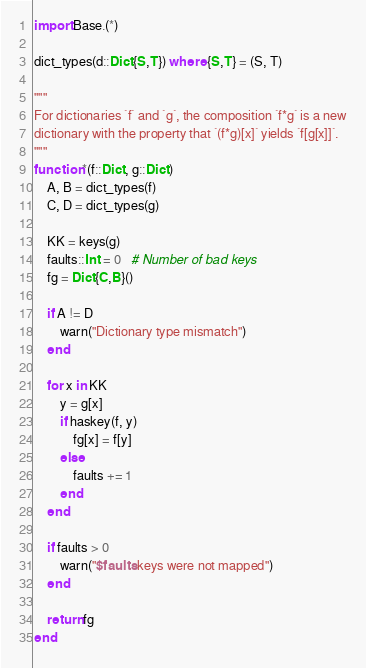<code> <loc_0><loc_0><loc_500><loc_500><_Julia_>import Base.(*)

dict_types(d::Dict{S,T}) where {S,T} = (S, T)

"""
For dictionaries `f` and `g`, the composition `f*g` is a new
dictionary with the property that `(f*g)[x]` yields `f[g[x]]`.
"""
function *(f::Dict, g::Dict)
    A, B = dict_types(f)
    C, D = dict_types(g)

    KK = keys(g)
    faults::Int = 0   # Number of bad keys
    fg = Dict{C,B}()

    if A != D
        warn("Dictionary type mismatch")
    end

    for x in KK
        y = g[x]
        if haskey(f, y)
            fg[x] = f[y]
        else
            faults += 1
        end
    end

    if faults > 0
        warn("$faults keys were not mapped")
    end

    return fg
end
</code> 